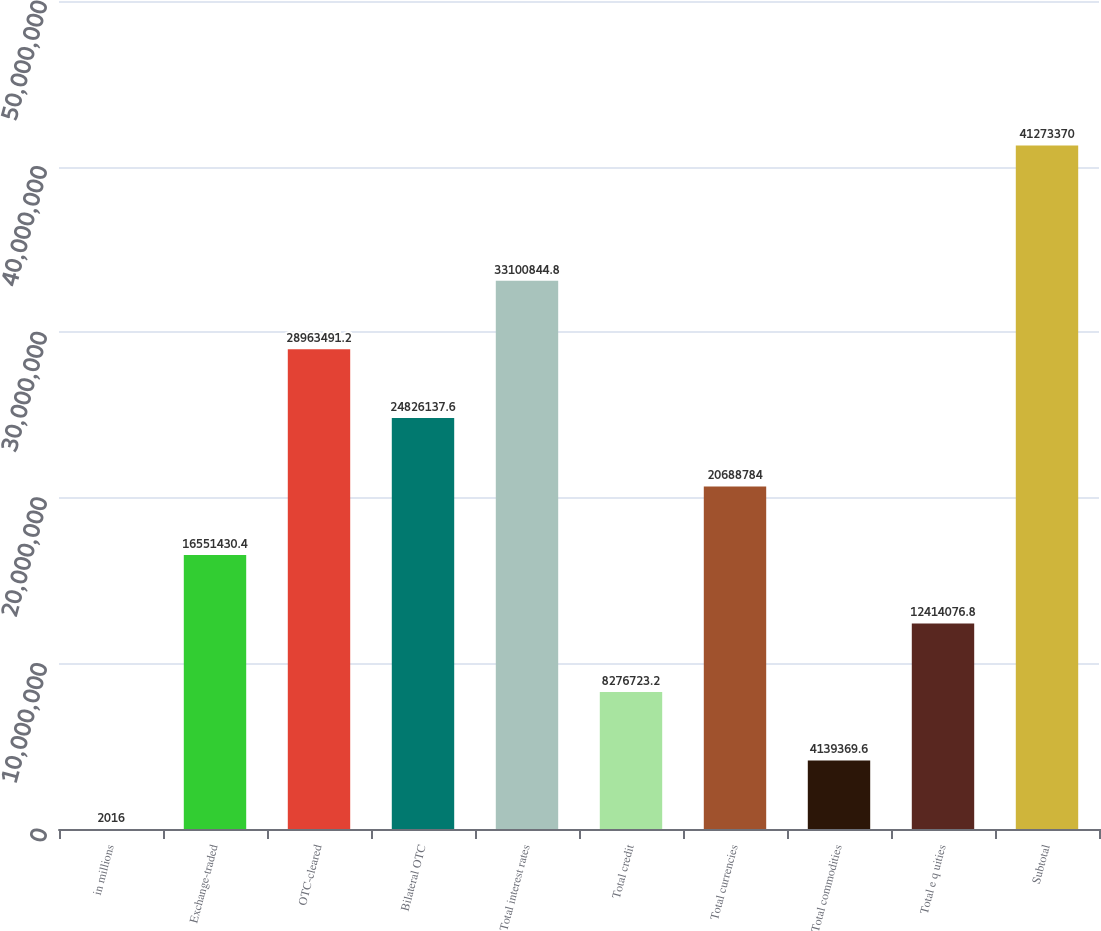<chart> <loc_0><loc_0><loc_500><loc_500><bar_chart><fcel>in millions<fcel>Exchange-traded<fcel>OTC-cleared<fcel>Bilateral OTC<fcel>Total interest rates<fcel>Total credit<fcel>Total currencies<fcel>Total commodities<fcel>Total e q uities<fcel>Subtotal<nl><fcel>2016<fcel>1.65514e+07<fcel>2.89635e+07<fcel>2.48261e+07<fcel>3.31008e+07<fcel>8.27672e+06<fcel>2.06888e+07<fcel>4.13937e+06<fcel>1.24141e+07<fcel>4.12734e+07<nl></chart> 